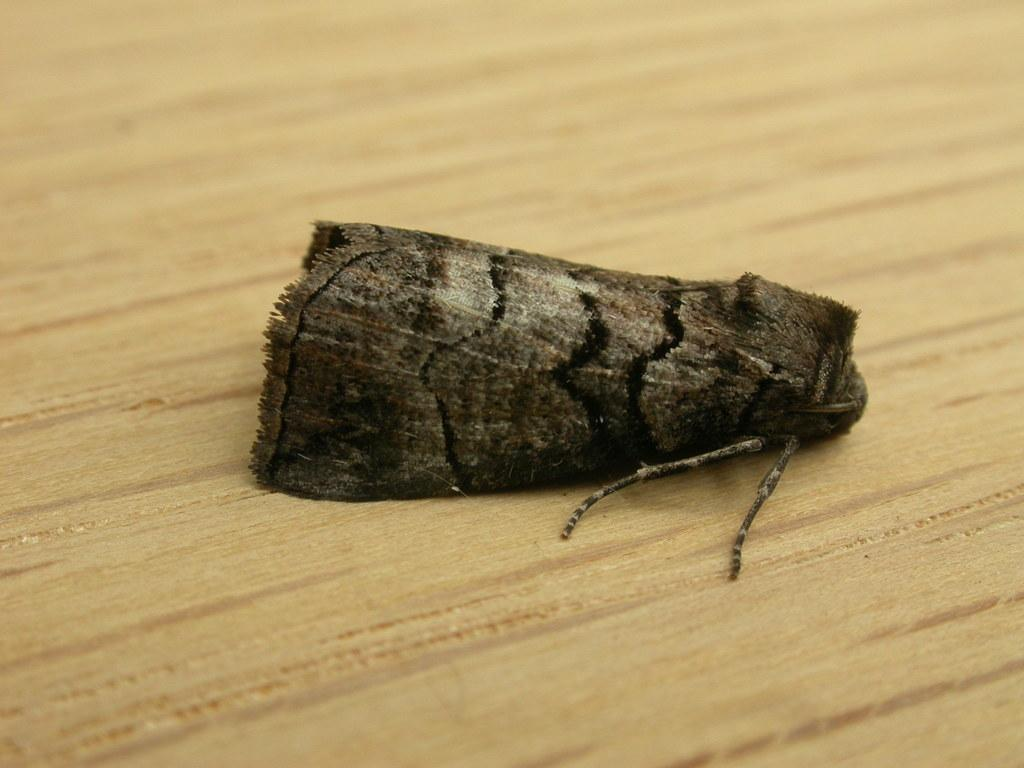What is the main subject of the image? The main subject of the image is a fly. Where is the fly located in the image? The fly is on a table in the image. Can you describe the position of the fly in the image? The fly is in the center of the image. What type of alarm is the fly activating in the image? There is no alarm present in the image; it only features a fly on a table. 